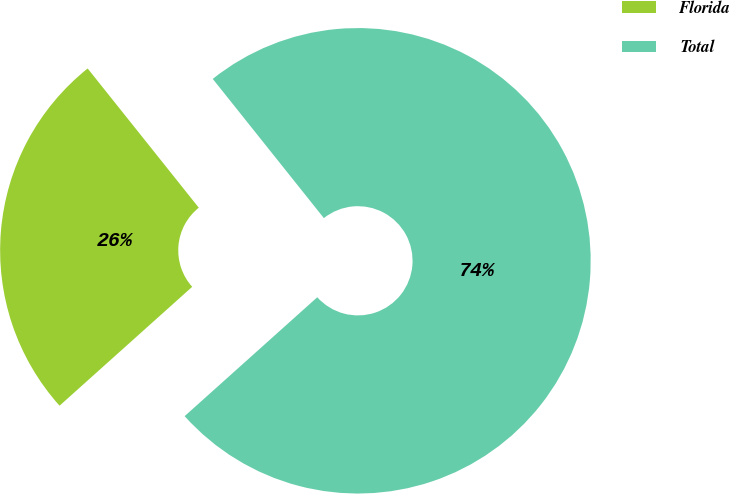<chart> <loc_0><loc_0><loc_500><loc_500><pie_chart><fcel>Florida<fcel>Total<nl><fcel>25.91%<fcel>74.09%<nl></chart> 